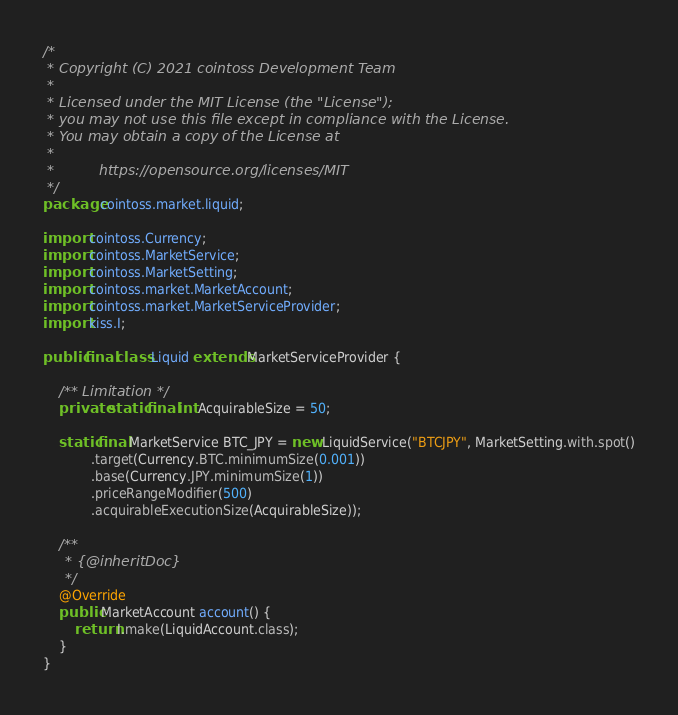Convert code to text. <code><loc_0><loc_0><loc_500><loc_500><_Java_>/*
 * Copyright (C) 2021 cointoss Development Team
 *
 * Licensed under the MIT License (the "License");
 * you may not use this file except in compliance with the License.
 * You may obtain a copy of the License at
 *
 *          https://opensource.org/licenses/MIT
 */
package cointoss.market.liquid;

import cointoss.Currency;
import cointoss.MarketService;
import cointoss.MarketSetting;
import cointoss.market.MarketAccount;
import cointoss.market.MarketServiceProvider;
import kiss.I;

public final class Liquid extends MarketServiceProvider {

    /** Limitation */
    private static final int AcquirableSize = 50;

    static final MarketService BTC_JPY = new LiquidService("BTCJPY", MarketSetting.with.spot()
            .target(Currency.BTC.minimumSize(0.001))
            .base(Currency.JPY.minimumSize(1))
            .priceRangeModifier(500)
            .acquirableExecutionSize(AcquirableSize));

    /**
     * {@inheritDoc}
     */
    @Override
    public MarketAccount account() {
        return I.make(LiquidAccount.class);
    }
}</code> 